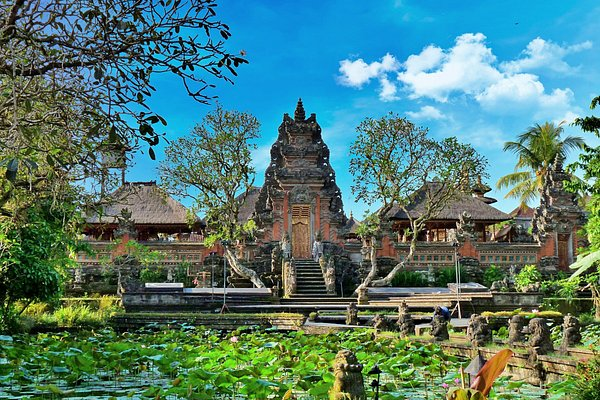If this place could tell a story, what do you think it would say? If the Ubud Water Palace could tell a story, it would speak of centuries of cultural pride and architectural mastery. It would tell of the craftsmen who meticulously carved its intricate details, the rituals and ceremonies held within its grounds, and the generations of visitors who have found peace and inspiration in its beauty. The palace would recount the harmony between human creativity and natural splendor, narrating tales of spiritual and artistic endeavors that have left an indelible mark on this land. It would whisper secrets of the past, echoing the voices of those who have walked its paths and touched its walls, weaving a rich tapestry of history, culture, and nature. 